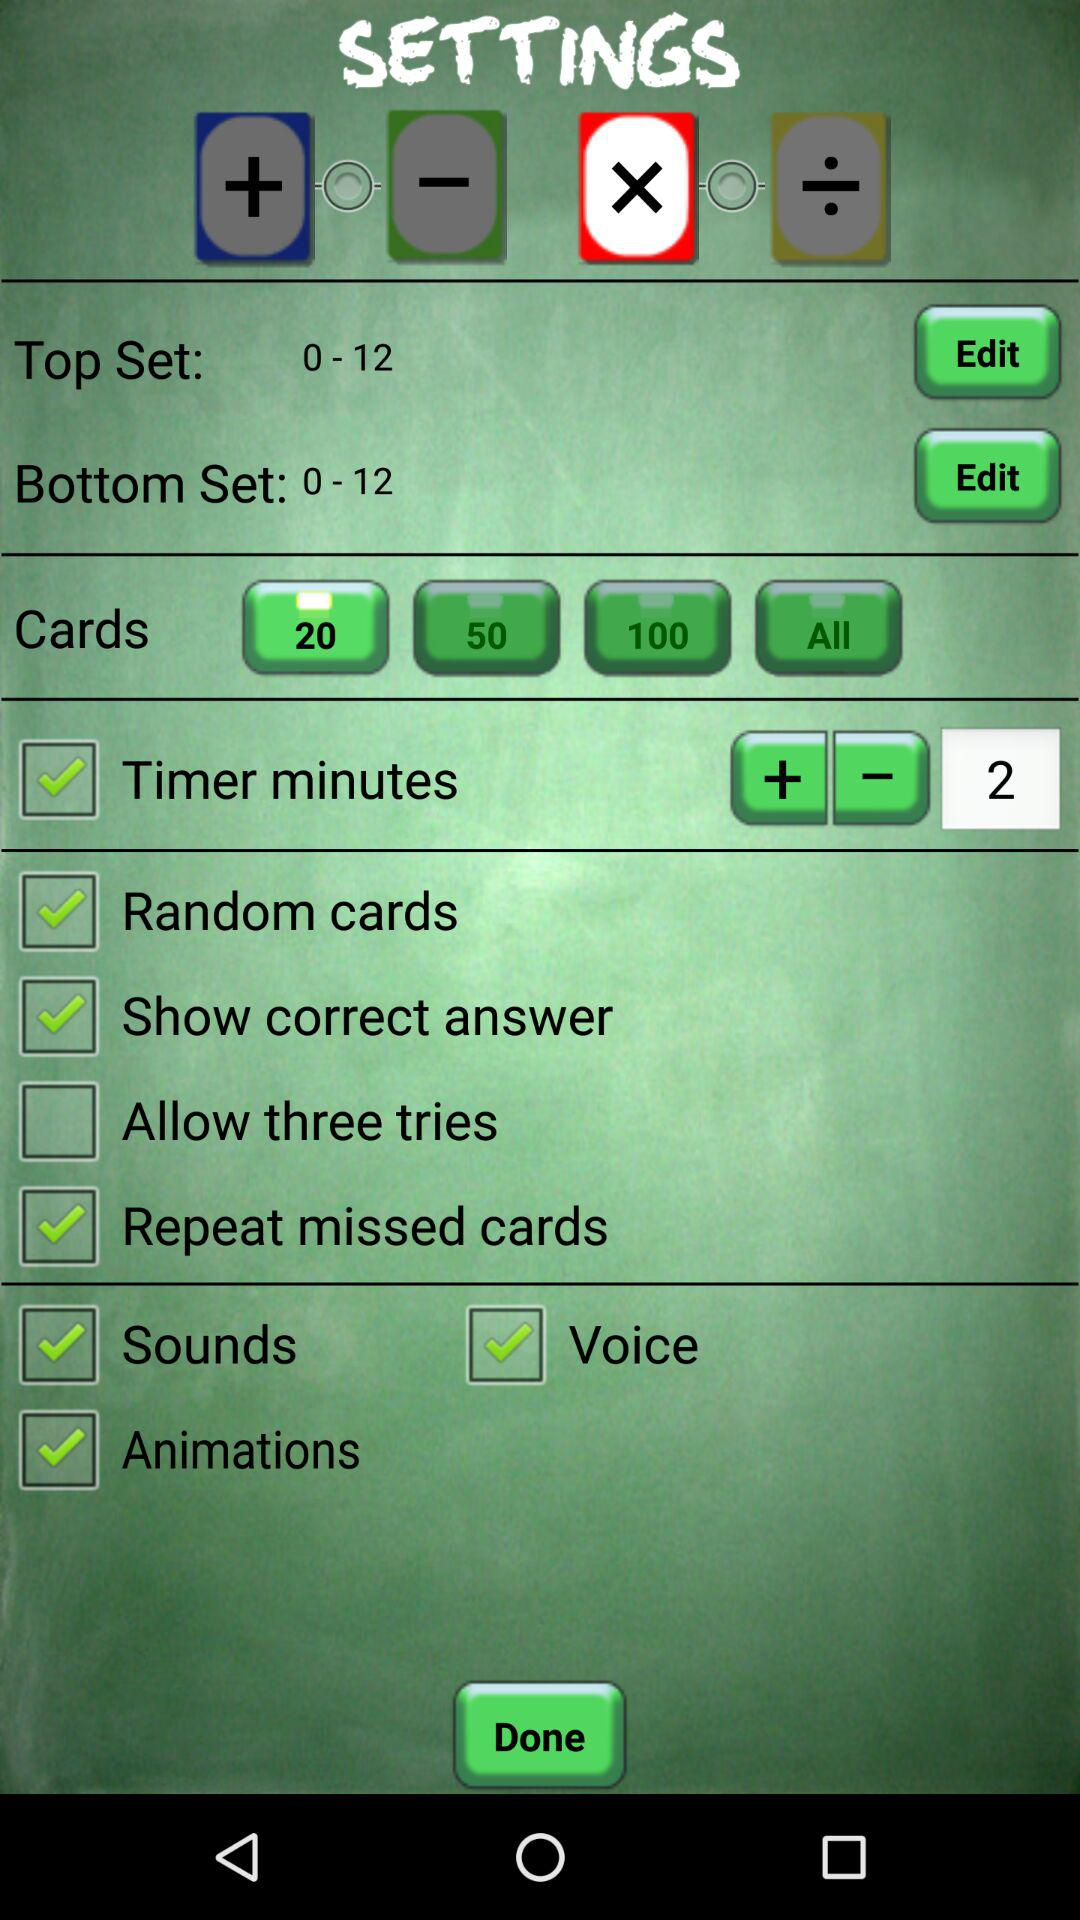At what time is the timer set for the minutes?
When the provided information is insufficient, respond with <no answer>. <no answer> 